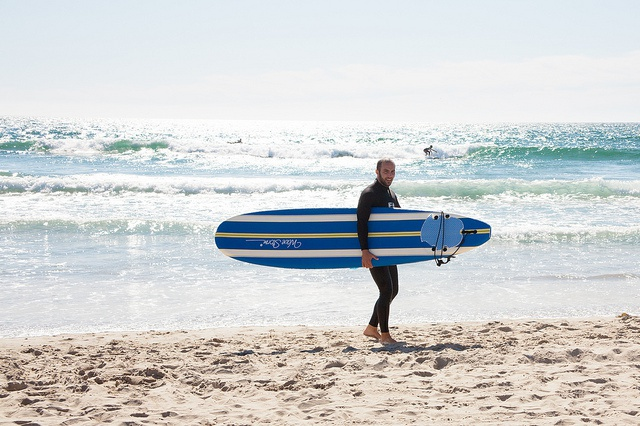Describe the objects in this image and their specific colors. I can see surfboard in lightgray, darkblue, blue, and darkgray tones, people in lightgray, black, gray, and navy tones, people in lightgray, black, gray, and darkgray tones, people in lightgray, gray, darkgray, and black tones, and people in lightgray, gray, darkgray, and white tones in this image. 